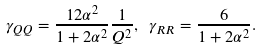<formula> <loc_0><loc_0><loc_500><loc_500>\gamma _ { Q Q } = \frac { 1 2 \alpha ^ { 2 } } { 1 + 2 \alpha ^ { 2 } } \frac { 1 } { Q ^ { 2 } } , \ \gamma _ { R R } = \frac { 6 } { 1 + 2 \alpha ^ { 2 } } .</formula> 